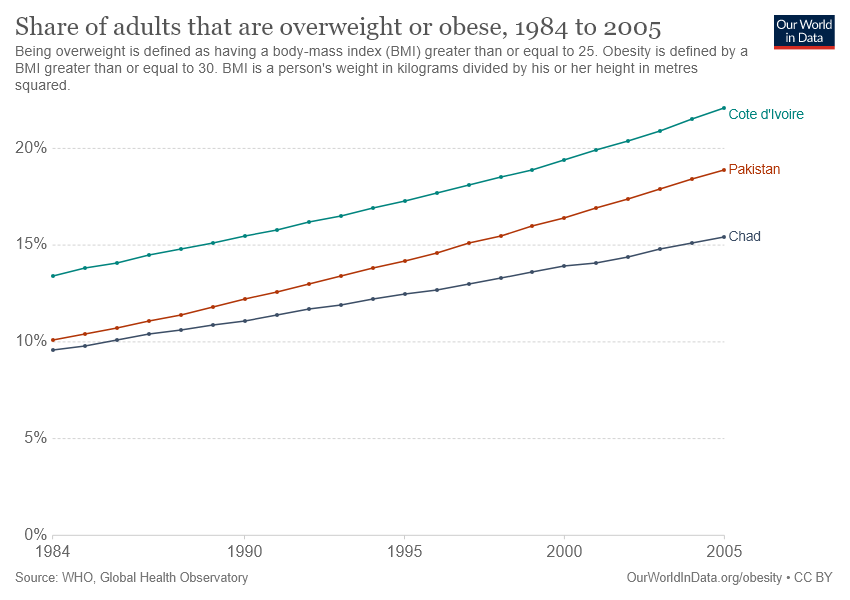Identify some key points in this picture. Cote d'Ivoire has the highest proportion of adults who are overweight. The country of Pakistan has a higher share of adults who are overweight compared to Chad over the years. 